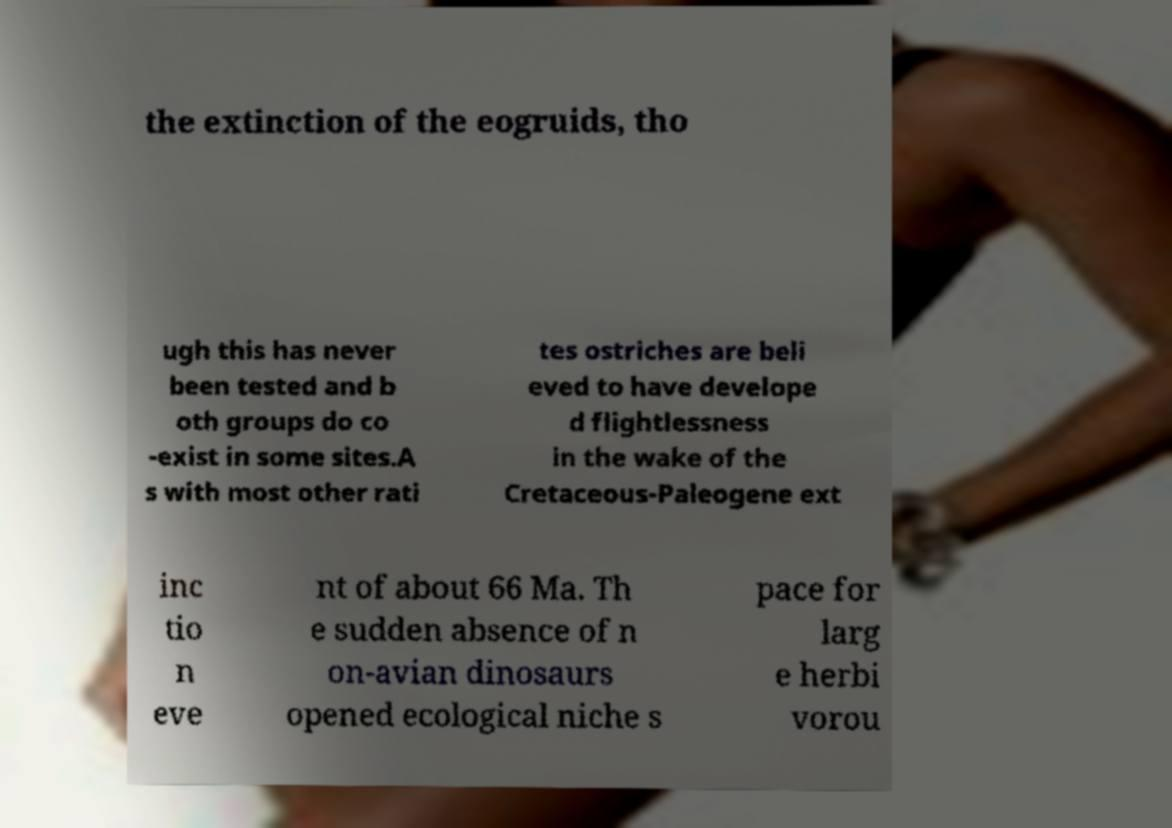Can you read and provide the text displayed in the image?This photo seems to have some interesting text. Can you extract and type it out for me? the extinction of the eogruids, tho ugh this has never been tested and b oth groups do co -exist in some sites.A s with most other rati tes ostriches are beli eved to have develope d flightlessness in the wake of the Cretaceous-Paleogene ext inc tio n eve nt of about 66 Ma. Th e sudden absence of n on-avian dinosaurs opened ecological niche s pace for larg e herbi vorou 